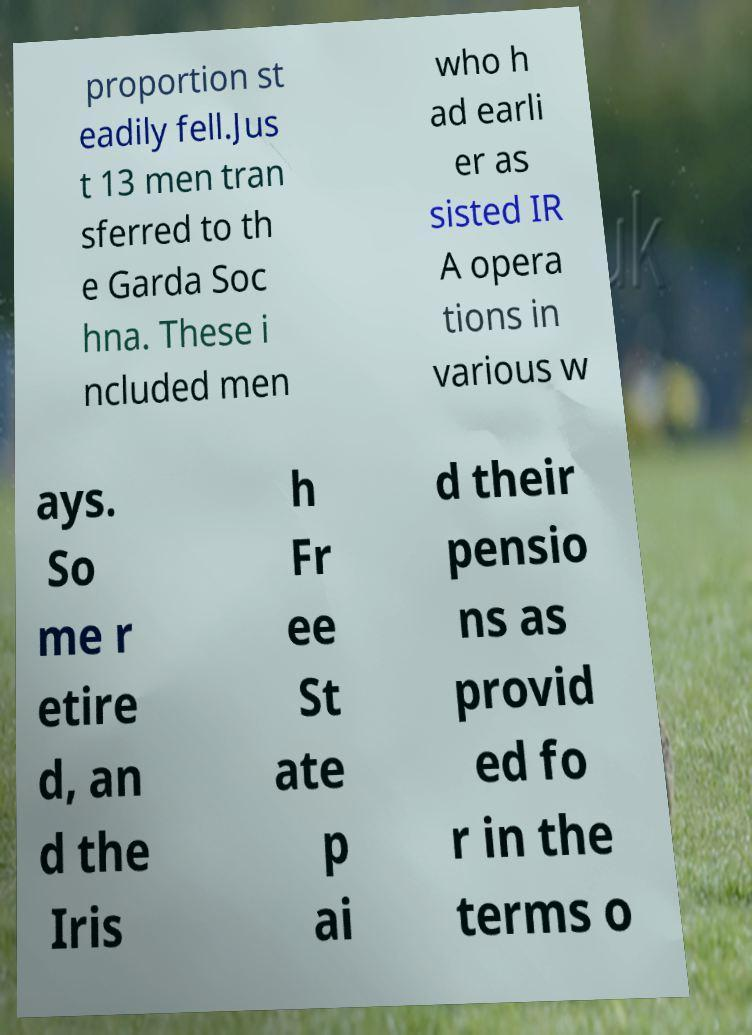Can you accurately transcribe the text from the provided image for me? proportion st eadily fell.Jus t 13 men tran sferred to th e Garda Soc hna. These i ncluded men who h ad earli er as sisted IR A opera tions in various w ays. So me r etire d, an d the Iris h Fr ee St ate p ai d their pensio ns as provid ed fo r in the terms o 